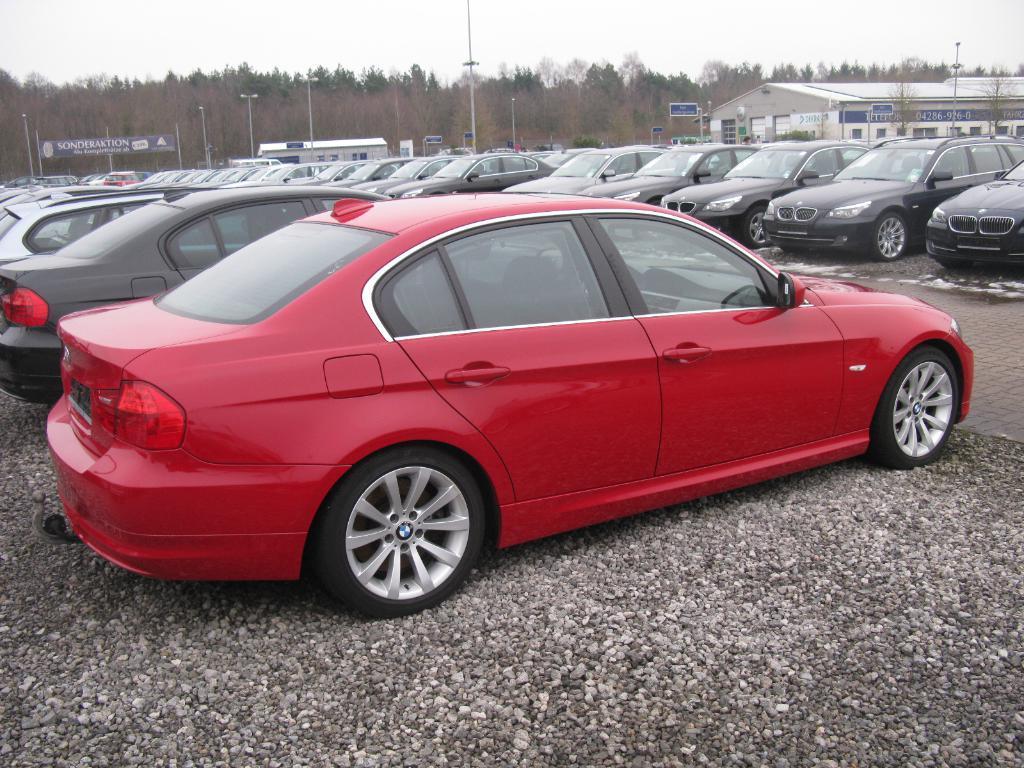Could you give a brief overview of what you see in this image? In this picture we can see some vehicles parked. Behind the vehicles there are poles, boards, a building, trees and the sky. 